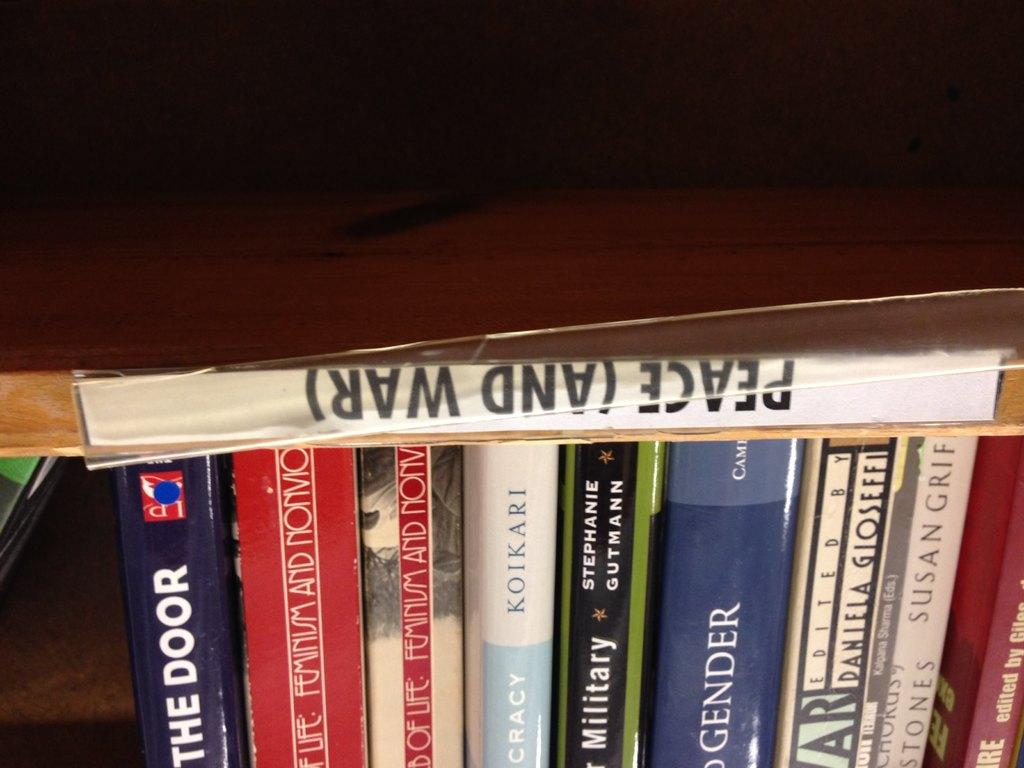<image>
Relay a brief, clear account of the picture shown. The book Peace and War sits above a stack of other books. 